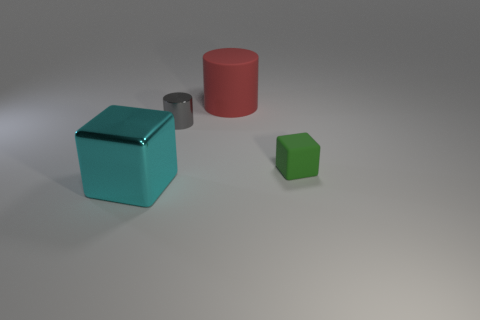Add 1 big cyan cubes. How many objects exist? 5 Add 4 gray shiny cylinders. How many gray shiny cylinders are left? 5 Add 1 tiny cyan metal balls. How many tiny cyan metal balls exist? 1 Subtract 0 green cylinders. How many objects are left? 4 Subtract all shiny things. Subtract all big things. How many objects are left? 0 